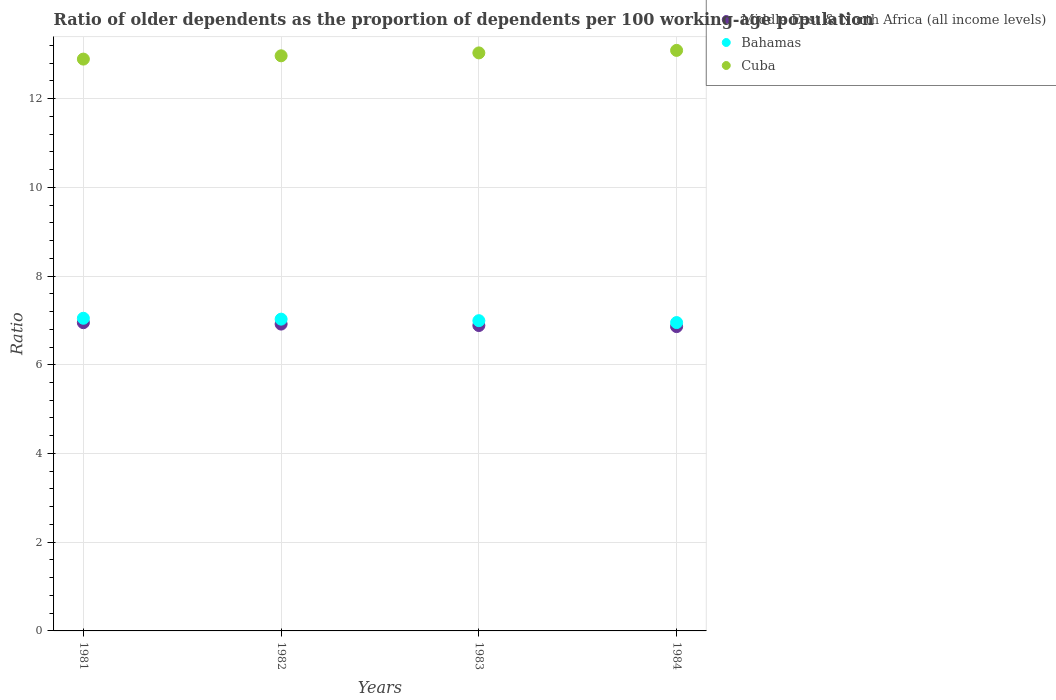Is the number of dotlines equal to the number of legend labels?
Provide a succinct answer. Yes. What is the age dependency ratio(old) in Middle East & North Africa (all income levels) in 1984?
Ensure brevity in your answer.  6.86. Across all years, what is the maximum age dependency ratio(old) in Middle East & North Africa (all income levels)?
Your response must be concise. 6.95. Across all years, what is the minimum age dependency ratio(old) in Middle East & North Africa (all income levels)?
Give a very brief answer. 6.86. In which year was the age dependency ratio(old) in Cuba maximum?
Your response must be concise. 1984. What is the total age dependency ratio(old) in Bahamas in the graph?
Offer a terse response. 28.02. What is the difference between the age dependency ratio(old) in Bahamas in 1982 and that in 1984?
Give a very brief answer. 0.08. What is the difference between the age dependency ratio(old) in Bahamas in 1981 and the age dependency ratio(old) in Middle East & North Africa (all income levels) in 1982?
Your answer should be very brief. 0.13. What is the average age dependency ratio(old) in Cuba per year?
Your response must be concise. 12.99. In the year 1981, what is the difference between the age dependency ratio(old) in Middle East & North Africa (all income levels) and age dependency ratio(old) in Bahamas?
Your response must be concise. -0.1. In how many years, is the age dependency ratio(old) in Middle East & North Africa (all income levels) greater than 8.4?
Your answer should be very brief. 0. What is the ratio of the age dependency ratio(old) in Bahamas in 1982 to that in 1983?
Offer a very short reply. 1. Is the difference between the age dependency ratio(old) in Middle East & North Africa (all income levels) in 1983 and 1984 greater than the difference between the age dependency ratio(old) in Bahamas in 1983 and 1984?
Make the answer very short. No. What is the difference between the highest and the second highest age dependency ratio(old) in Bahamas?
Make the answer very short. 0.02. What is the difference between the highest and the lowest age dependency ratio(old) in Middle East & North Africa (all income levels)?
Your answer should be very brief. 0.09. Is it the case that in every year, the sum of the age dependency ratio(old) in Cuba and age dependency ratio(old) in Bahamas  is greater than the age dependency ratio(old) in Middle East & North Africa (all income levels)?
Provide a succinct answer. Yes. How many dotlines are there?
Ensure brevity in your answer.  3. How many years are there in the graph?
Make the answer very short. 4. Are the values on the major ticks of Y-axis written in scientific E-notation?
Keep it short and to the point. No. Does the graph contain grids?
Provide a short and direct response. Yes. Where does the legend appear in the graph?
Keep it short and to the point. Top right. How many legend labels are there?
Keep it short and to the point. 3. What is the title of the graph?
Provide a succinct answer. Ratio of older dependents as the proportion of dependents per 100 working-age population. What is the label or title of the Y-axis?
Provide a succinct answer. Ratio. What is the Ratio in Middle East & North Africa (all income levels) in 1981?
Your answer should be very brief. 6.95. What is the Ratio in Bahamas in 1981?
Offer a very short reply. 7.05. What is the Ratio in Cuba in 1981?
Offer a very short reply. 12.89. What is the Ratio in Middle East & North Africa (all income levels) in 1982?
Offer a very short reply. 6.92. What is the Ratio in Bahamas in 1982?
Keep it short and to the point. 7.03. What is the Ratio in Cuba in 1982?
Your answer should be compact. 12.96. What is the Ratio in Middle East & North Africa (all income levels) in 1983?
Your answer should be very brief. 6.88. What is the Ratio in Bahamas in 1983?
Offer a terse response. 6.99. What is the Ratio in Cuba in 1983?
Your answer should be compact. 13.03. What is the Ratio of Middle East & North Africa (all income levels) in 1984?
Your answer should be very brief. 6.86. What is the Ratio of Bahamas in 1984?
Keep it short and to the point. 6.95. What is the Ratio in Cuba in 1984?
Provide a succinct answer. 13.09. Across all years, what is the maximum Ratio of Middle East & North Africa (all income levels)?
Offer a terse response. 6.95. Across all years, what is the maximum Ratio in Bahamas?
Give a very brief answer. 7.05. Across all years, what is the maximum Ratio in Cuba?
Give a very brief answer. 13.09. Across all years, what is the minimum Ratio of Middle East & North Africa (all income levels)?
Provide a succinct answer. 6.86. Across all years, what is the minimum Ratio of Bahamas?
Ensure brevity in your answer.  6.95. Across all years, what is the minimum Ratio in Cuba?
Keep it short and to the point. 12.89. What is the total Ratio of Middle East & North Africa (all income levels) in the graph?
Your answer should be very brief. 27.61. What is the total Ratio of Bahamas in the graph?
Your response must be concise. 28.02. What is the total Ratio of Cuba in the graph?
Your response must be concise. 51.97. What is the difference between the Ratio of Middle East & North Africa (all income levels) in 1981 and that in 1982?
Provide a short and direct response. 0.03. What is the difference between the Ratio of Cuba in 1981 and that in 1982?
Your answer should be compact. -0.07. What is the difference between the Ratio of Middle East & North Africa (all income levels) in 1981 and that in 1983?
Your answer should be very brief. 0.06. What is the difference between the Ratio in Bahamas in 1981 and that in 1983?
Your answer should be very brief. 0.05. What is the difference between the Ratio in Cuba in 1981 and that in 1983?
Your answer should be compact. -0.14. What is the difference between the Ratio of Middle East & North Africa (all income levels) in 1981 and that in 1984?
Ensure brevity in your answer.  0.09. What is the difference between the Ratio of Bahamas in 1981 and that in 1984?
Your answer should be compact. 0.1. What is the difference between the Ratio in Cuba in 1981 and that in 1984?
Ensure brevity in your answer.  -0.2. What is the difference between the Ratio in Middle East & North Africa (all income levels) in 1982 and that in 1983?
Make the answer very short. 0.03. What is the difference between the Ratio in Bahamas in 1982 and that in 1983?
Give a very brief answer. 0.03. What is the difference between the Ratio in Cuba in 1982 and that in 1983?
Make the answer very short. -0.07. What is the difference between the Ratio in Middle East & North Africa (all income levels) in 1982 and that in 1984?
Keep it short and to the point. 0.06. What is the difference between the Ratio of Bahamas in 1982 and that in 1984?
Ensure brevity in your answer.  0.08. What is the difference between the Ratio of Cuba in 1982 and that in 1984?
Keep it short and to the point. -0.12. What is the difference between the Ratio in Middle East & North Africa (all income levels) in 1983 and that in 1984?
Keep it short and to the point. 0.02. What is the difference between the Ratio in Bahamas in 1983 and that in 1984?
Ensure brevity in your answer.  0.04. What is the difference between the Ratio in Cuba in 1983 and that in 1984?
Make the answer very short. -0.06. What is the difference between the Ratio in Middle East & North Africa (all income levels) in 1981 and the Ratio in Bahamas in 1982?
Give a very brief answer. -0.08. What is the difference between the Ratio of Middle East & North Africa (all income levels) in 1981 and the Ratio of Cuba in 1982?
Ensure brevity in your answer.  -6.02. What is the difference between the Ratio of Bahamas in 1981 and the Ratio of Cuba in 1982?
Offer a very short reply. -5.92. What is the difference between the Ratio in Middle East & North Africa (all income levels) in 1981 and the Ratio in Bahamas in 1983?
Give a very brief answer. -0.05. What is the difference between the Ratio of Middle East & North Africa (all income levels) in 1981 and the Ratio of Cuba in 1983?
Your answer should be very brief. -6.08. What is the difference between the Ratio in Bahamas in 1981 and the Ratio in Cuba in 1983?
Offer a very short reply. -5.98. What is the difference between the Ratio in Middle East & North Africa (all income levels) in 1981 and the Ratio in Bahamas in 1984?
Offer a very short reply. -0. What is the difference between the Ratio of Middle East & North Africa (all income levels) in 1981 and the Ratio of Cuba in 1984?
Ensure brevity in your answer.  -6.14. What is the difference between the Ratio in Bahamas in 1981 and the Ratio in Cuba in 1984?
Make the answer very short. -6.04. What is the difference between the Ratio of Middle East & North Africa (all income levels) in 1982 and the Ratio of Bahamas in 1983?
Provide a short and direct response. -0.08. What is the difference between the Ratio in Middle East & North Africa (all income levels) in 1982 and the Ratio in Cuba in 1983?
Make the answer very short. -6.11. What is the difference between the Ratio in Bahamas in 1982 and the Ratio in Cuba in 1983?
Your response must be concise. -6. What is the difference between the Ratio of Middle East & North Africa (all income levels) in 1982 and the Ratio of Bahamas in 1984?
Provide a short and direct response. -0.03. What is the difference between the Ratio of Middle East & North Africa (all income levels) in 1982 and the Ratio of Cuba in 1984?
Give a very brief answer. -6.17. What is the difference between the Ratio in Bahamas in 1982 and the Ratio in Cuba in 1984?
Provide a succinct answer. -6.06. What is the difference between the Ratio of Middle East & North Africa (all income levels) in 1983 and the Ratio of Bahamas in 1984?
Your answer should be very brief. -0.07. What is the difference between the Ratio of Middle East & North Africa (all income levels) in 1983 and the Ratio of Cuba in 1984?
Offer a very short reply. -6.2. What is the difference between the Ratio in Bahamas in 1983 and the Ratio in Cuba in 1984?
Offer a very short reply. -6.09. What is the average Ratio of Middle East & North Africa (all income levels) per year?
Make the answer very short. 6.9. What is the average Ratio in Bahamas per year?
Offer a very short reply. 7.01. What is the average Ratio in Cuba per year?
Make the answer very short. 12.99. In the year 1981, what is the difference between the Ratio in Middle East & North Africa (all income levels) and Ratio in Bahamas?
Provide a succinct answer. -0.1. In the year 1981, what is the difference between the Ratio in Middle East & North Africa (all income levels) and Ratio in Cuba?
Ensure brevity in your answer.  -5.94. In the year 1981, what is the difference between the Ratio of Bahamas and Ratio of Cuba?
Offer a terse response. -5.84. In the year 1982, what is the difference between the Ratio in Middle East & North Africa (all income levels) and Ratio in Bahamas?
Ensure brevity in your answer.  -0.11. In the year 1982, what is the difference between the Ratio in Middle East & North Africa (all income levels) and Ratio in Cuba?
Offer a terse response. -6.05. In the year 1982, what is the difference between the Ratio in Bahamas and Ratio in Cuba?
Your answer should be very brief. -5.94. In the year 1983, what is the difference between the Ratio in Middle East & North Africa (all income levels) and Ratio in Bahamas?
Your response must be concise. -0.11. In the year 1983, what is the difference between the Ratio in Middle East & North Africa (all income levels) and Ratio in Cuba?
Your answer should be compact. -6.15. In the year 1983, what is the difference between the Ratio in Bahamas and Ratio in Cuba?
Provide a succinct answer. -6.04. In the year 1984, what is the difference between the Ratio in Middle East & North Africa (all income levels) and Ratio in Bahamas?
Your answer should be very brief. -0.09. In the year 1984, what is the difference between the Ratio in Middle East & North Africa (all income levels) and Ratio in Cuba?
Your answer should be compact. -6.23. In the year 1984, what is the difference between the Ratio of Bahamas and Ratio of Cuba?
Your answer should be very brief. -6.14. What is the ratio of the Ratio in Middle East & North Africa (all income levels) in 1981 to that in 1983?
Provide a succinct answer. 1.01. What is the ratio of the Ratio of Cuba in 1981 to that in 1983?
Offer a very short reply. 0.99. What is the ratio of the Ratio in Middle East & North Africa (all income levels) in 1981 to that in 1984?
Ensure brevity in your answer.  1.01. What is the ratio of the Ratio of Bahamas in 1981 to that in 1984?
Provide a succinct answer. 1.01. What is the ratio of the Ratio of Middle East & North Africa (all income levels) in 1982 to that in 1983?
Offer a very short reply. 1. What is the ratio of the Ratio in Middle East & North Africa (all income levels) in 1982 to that in 1984?
Provide a short and direct response. 1.01. What is the ratio of the Ratio in Bahamas in 1982 to that in 1984?
Ensure brevity in your answer.  1.01. What is the ratio of the Ratio in Middle East & North Africa (all income levels) in 1983 to that in 1984?
Offer a terse response. 1. What is the ratio of the Ratio of Bahamas in 1983 to that in 1984?
Ensure brevity in your answer.  1.01. What is the difference between the highest and the second highest Ratio of Middle East & North Africa (all income levels)?
Offer a very short reply. 0.03. What is the difference between the highest and the second highest Ratio of Cuba?
Make the answer very short. 0.06. What is the difference between the highest and the lowest Ratio of Middle East & North Africa (all income levels)?
Ensure brevity in your answer.  0.09. What is the difference between the highest and the lowest Ratio of Bahamas?
Offer a terse response. 0.1. What is the difference between the highest and the lowest Ratio in Cuba?
Make the answer very short. 0.2. 